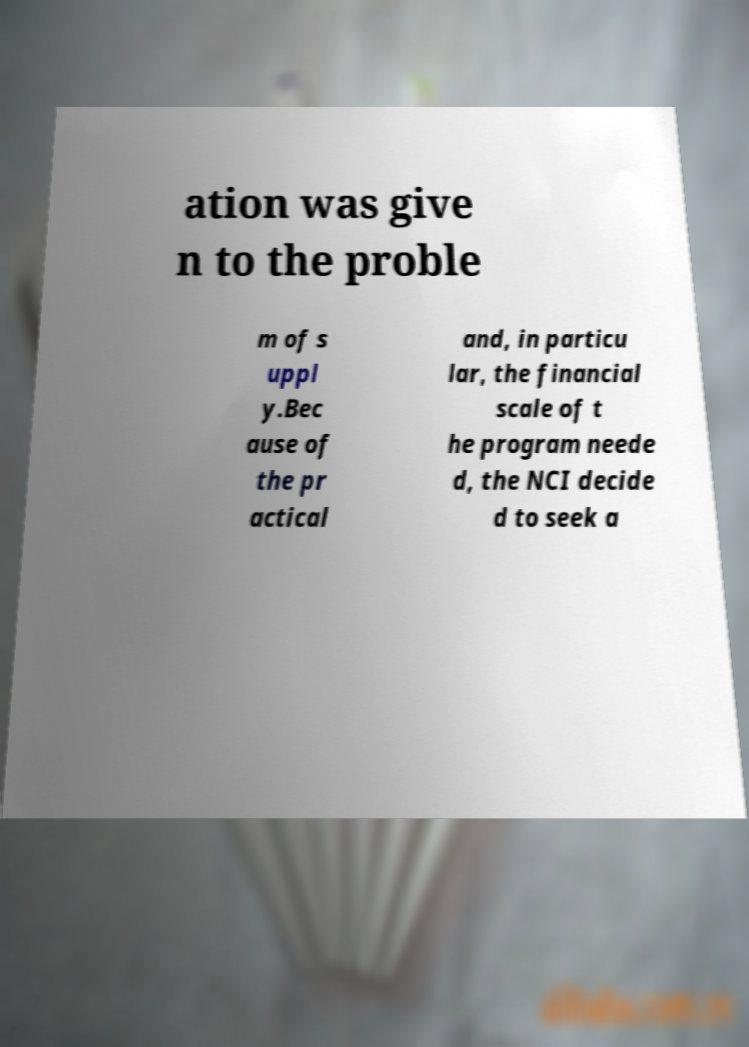Could you extract and type out the text from this image? ation was give n to the proble m of s uppl y.Bec ause of the pr actical and, in particu lar, the financial scale of t he program neede d, the NCI decide d to seek a 